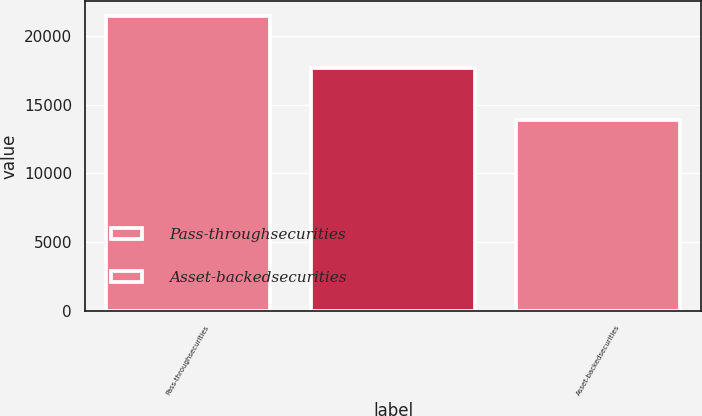Convert chart. <chart><loc_0><loc_0><loc_500><loc_500><bar_chart><fcel>Pass-throughsecurities<fcel>Unnamed: 1<fcel>Asset-backedsecurities<nl><fcel>21444.4<fcel>17666.7<fcel>13889<nl></chart> 